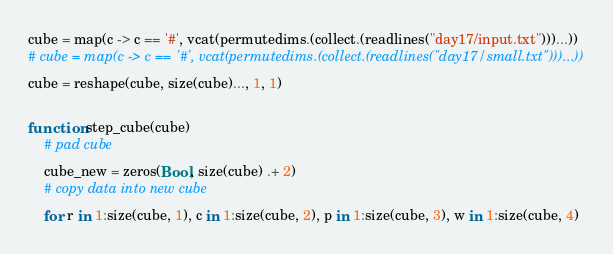<code> <loc_0><loc_0><loc_500><loc_500><_Julia_>cube = map(c -> c == '#', vcat(permutedims.(collect.(readlines("day17/input.txt")))...))
# cube = map(c -> c == '#', vcat(permutedims.(collect.(readlines("day17/small.txt")))...))
cube = reshape(cube, size(cube)..., 1, 1)

function step_cube(cube)
    # pad cube
    cube_new = zeros(Bool, size(cube) .+ 2)
    # copy data into new cube
    for r in 1:size(cube, 1), c in 1:size(cube, 2), p in 1:size(cube, 3), w in 1:size(cube, 4)</code> 